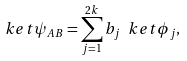Convert formula to latex. <formula><loc_0><loc_0><loc_500><loc_500>\ k e t \psi _ { A B } = \sum _ { j = 1 } ^ { 2 k } b _ { j } \ k e t { \phi _ { j } } ,</formula> 